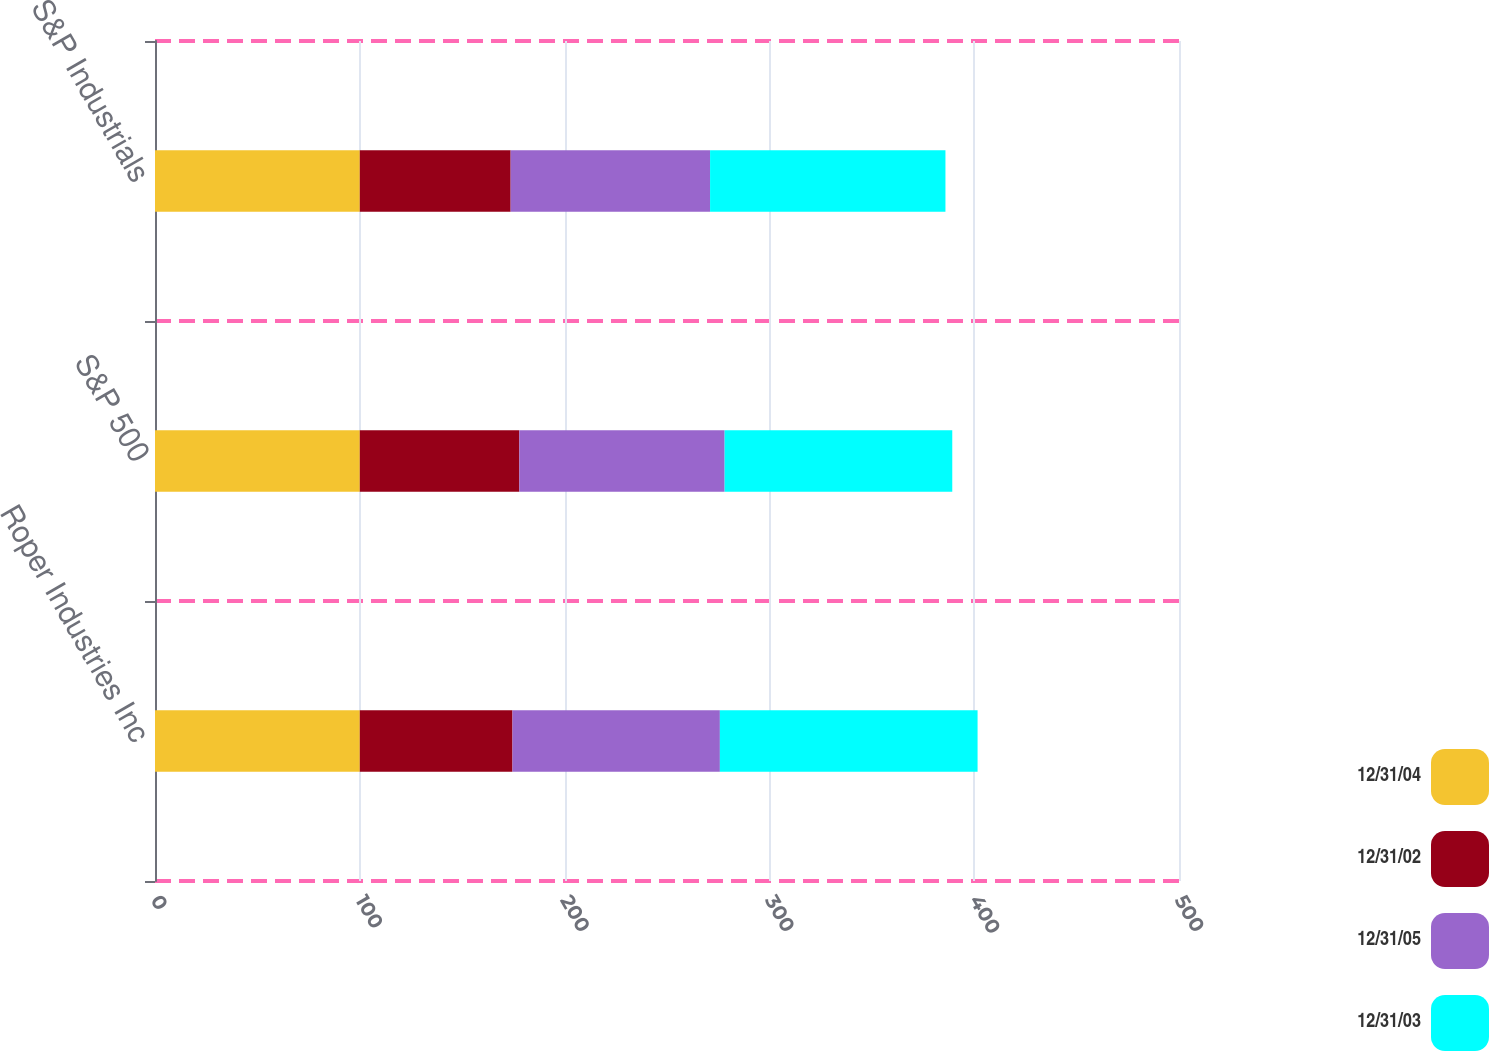<chart> <loc_0><loc_0><loc_500><loc_500><stacked_bar_chart><ecel><fcel>Roper Industries Inc<fcel>S&P 500<fcel>S&P Industrials<nl><fcel>12/31/04<fcel>100<fcel>100<fcel>100<nl><fcel>12/31/02<fcel>74.55<fcel>77.9<fcel>73.66<nl><fcel>12/31/05<fcel>101.27<fcel>100.24<fcel>97.37<nl><fcel>12/31/03<fcel>125.83<fcel>111.15<fcel>114.93<nl></chart> 